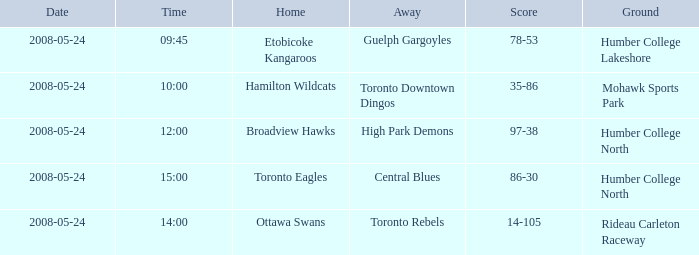Who was the home team of the game at the time of 14:00? Ottawa Swans. 